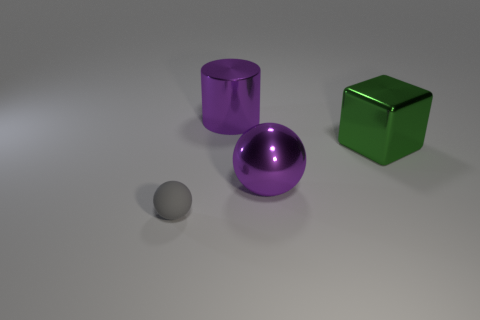Add 1 purple shiny things. How many objects exist? 5 Subtract all balls. Subtract all large green objects. How many objects are left? 1 Add 3 small objects. How many small objects are left? 4 Add 3 big yellow metallic cylinders. How many big yellow metallic cylinders exist? 3 Subtract all purple balls. How many balls are left? 1 Subtract 0 yellow cylinders. How many objects are left? 4 Subtract all cylinders. How many objects are left? 3 Subtract 2 balls. How many balls are left? 0 Subtract all purple spheres. Subtract all green cubes. How many spheres are left? 1 Subtract all brown balls. How many green cylinders are left? 0 